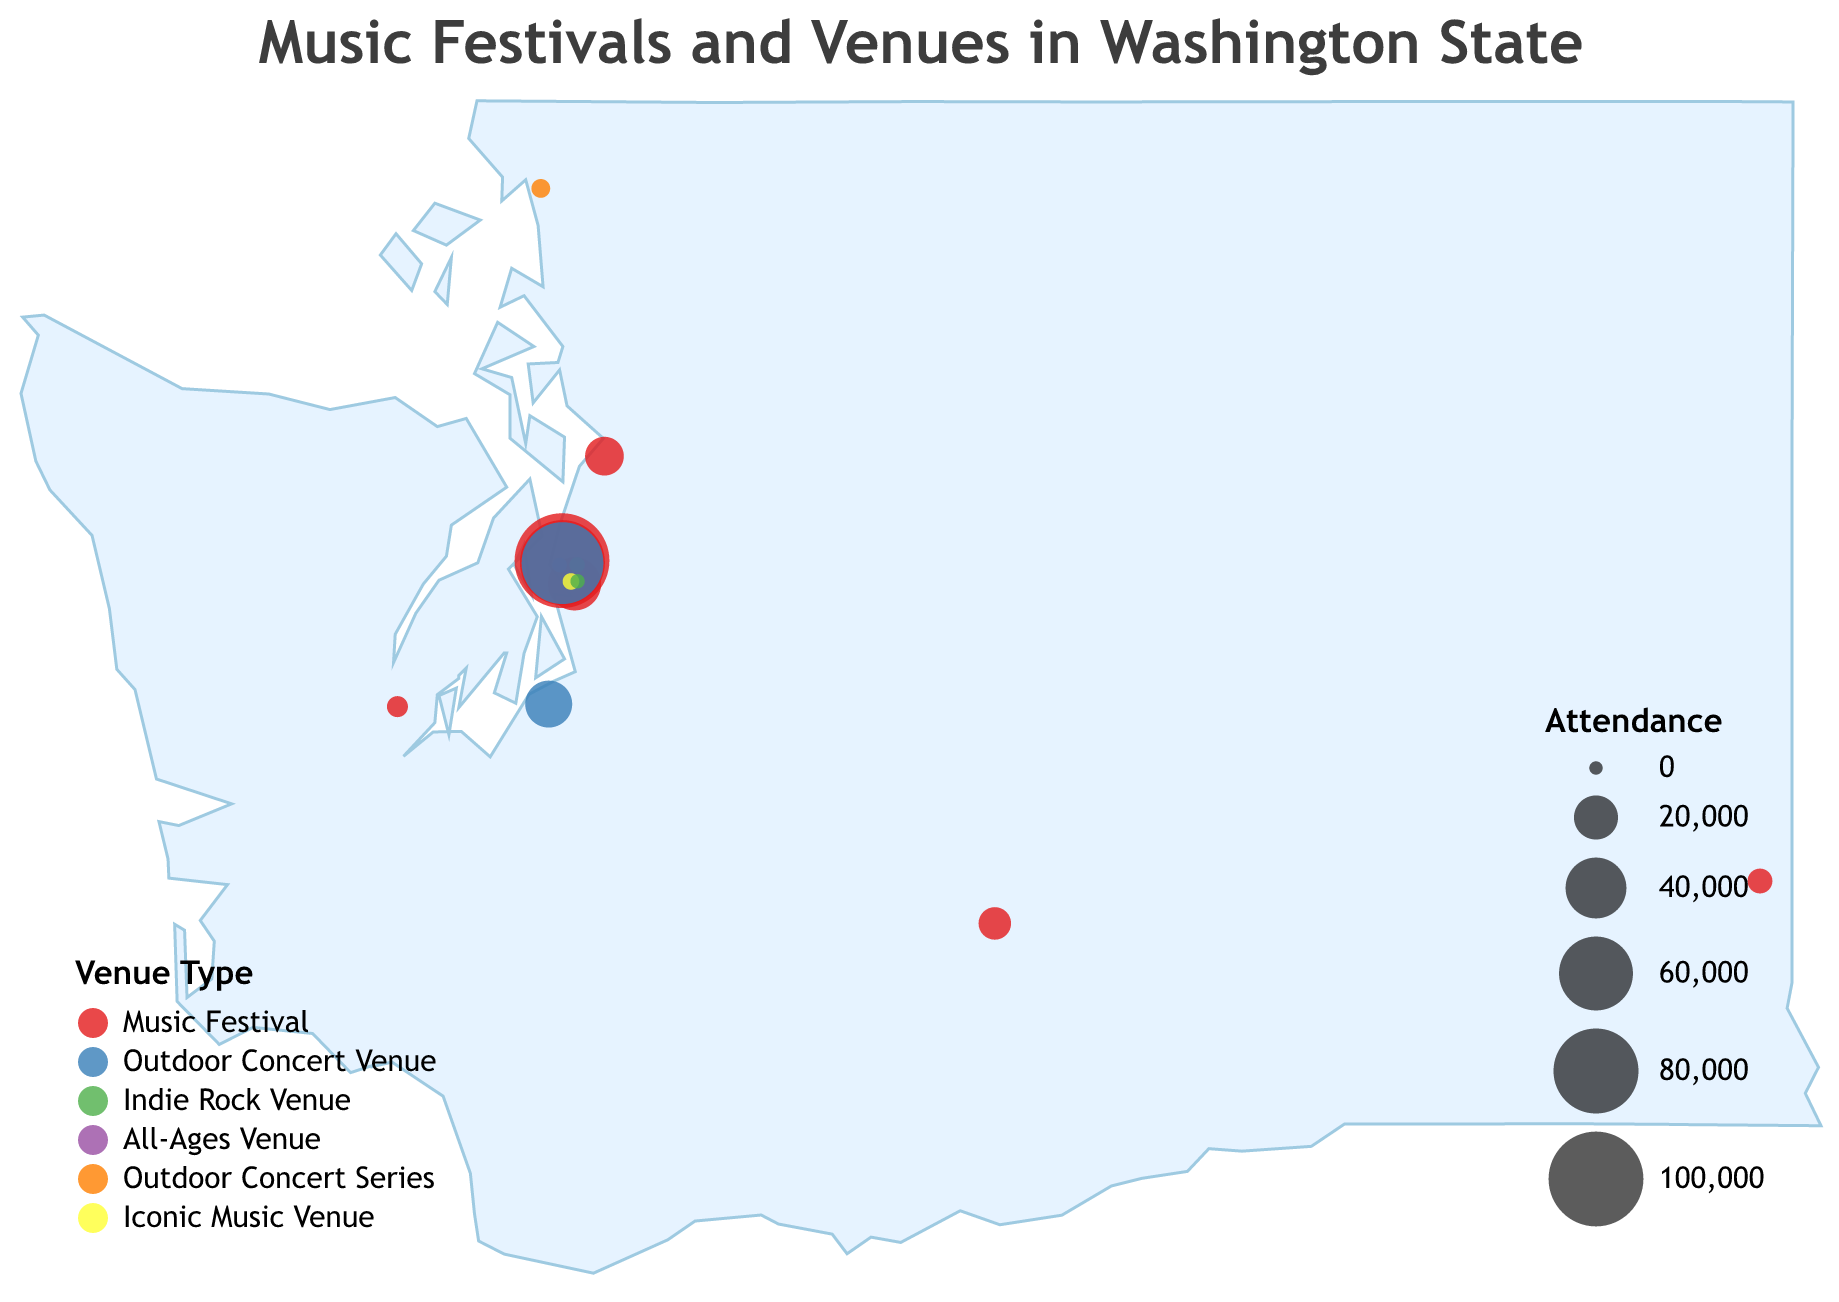What's the title of the figure? The title is prominently displayed at the top of the figure in a larger font. It reads, "Music Festivals and Venues in Washington State".
Answer: Music Festivals and Venues in Washington State How many types of venues are shown in the legend? The legend for venue types is located at the bottom-left of the figure. Counting the distinct colors and names, there are six types of venues: Music Festival, Outdoor Concert Venue, Indie Rock Venue, All-Ages Venue, Outdoor Concert Series, and Iconic Music Venue.
Answer: Six types Which venue has the highest attendance, and what is its attendance? Observing the circle sizes and tooltips, the largest circle and thus the highest attendance is for "Fremont Fair" with an attendance of 100,000.
Answer: Fremont Fair, 100,000 How many venues are located in Seattle? By identifying the clusters around the geographic coordinates of Seattle (latitude approximately 47.6062 and longitude approximately -122.3321), count the number of distinct venues. There are seven venues: Capitol Hill Block Party, Bumbershoot, Neumos, The Crocodile, The Vera Project, The Showbox, and Chop Suey.
Answer: Seven venues What is the difference in attendance between Bumbershoot and the Timber! Outdoor Music Festival? By looking at the tooltips for Bumbershoot and Timber! Outdoor Music Festival, Bumbershoot has an attendance of 80,000 and Timber! has 3,000. Subtracting the two gives 80,000 - 3,000 = 77,000.
Answer: 77,000 Which venue type appears most frequently in the figure? By counting each type in the legend and their corresponding circles in the plot, "Music Festival" appears the most frequently with seven instances.
Answer: Music Festival Are all the "Indie Rock Venues" located in the same city? By examining the geographic coordinates and the type labels of "Indie Rock Venue", all such venues (Neumos, The Crocodile, and Chop Suey) are centered around Seattle.
Answer: Yes What is the average attendance of all "Music Festivals"? There are seven music festivals with attendances of 30,000, 80,000, 5,000, 15,000, 3,000, 100,000, and 10,000. Summing these gives 243,000, and the average is 243,000 divided by 7, which equals 34,714.
Answer: 34,714 Which venue type has the smallest circle size, and what is the attendance associated with it? Examining the circle sizes and the legend, the smallest circle size corresponds to "The Vera Project" (an All-Ages Venue) with an attendance of 400.
Answer: All-Ages Venue, 400 Name the southernmost and northernmost music venues on the map. Observing the latitude values, the southernmost venue is the "Yakima Folklife Festival" (latitude 46.6021) and the northernmost is the "Downtown Sounds Concert Series" (latitude 48.7519).
Answer: Yakima Folklife Festival and Downtown Sounds Concert Series 